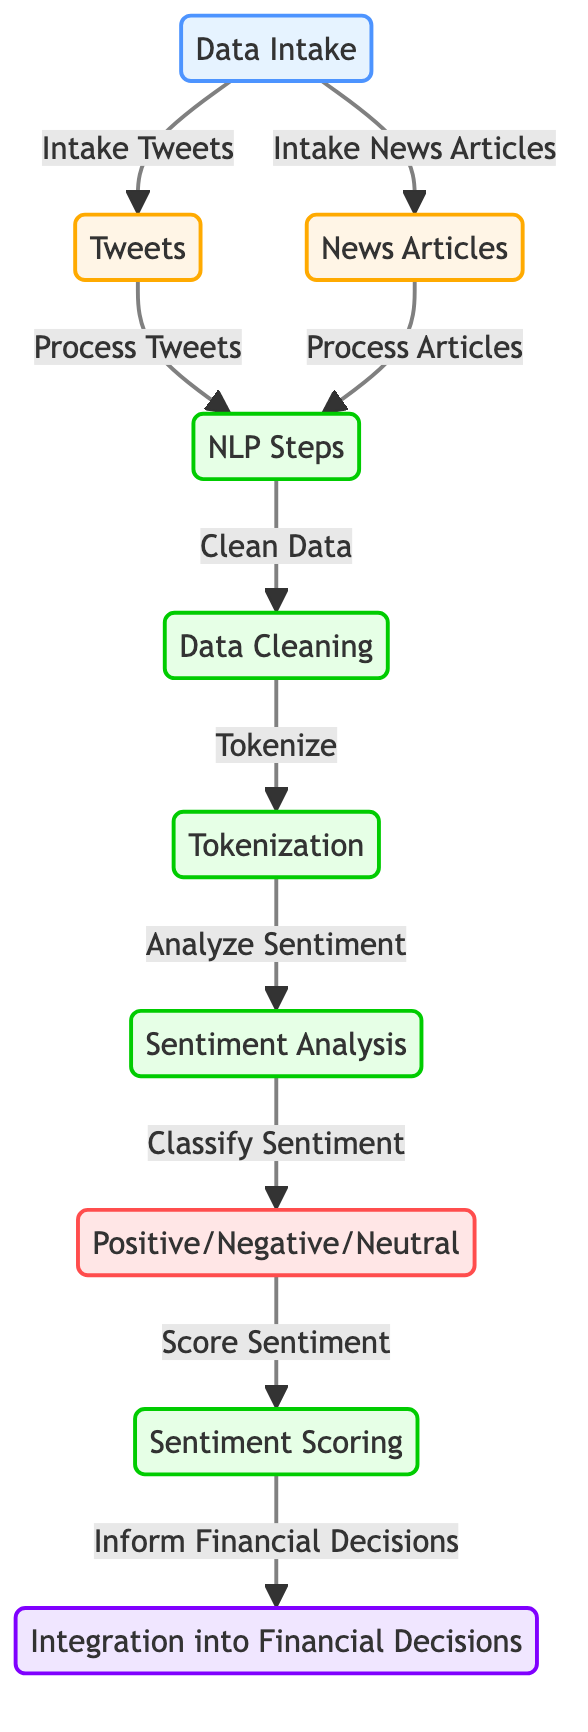What are the two sources of data intake in the diagram? The diagram indicates two sources for data intake: tweets and news articles, as labeled in the Data Intake node.
Answer: Tweets, news articles How many NLP steps are shown in the diagram? The diagram shows four steps under NLP: Data Cleaning, Tokenization, Sentiment Analysis, and Sentiment Scoring, which can be counted directly from the NLP Steps node leading downwards.
Answer: Four What is the final output of the diagram? The final output of the diagram is the Integration into Financial Decisions, which is the last node processed after scoring sentiment.
Answer: Integration into Financial Decisions What is the purpose of the Sentiment Analysis step? The Sentiment Analysis step classifies the sentiments from the processed text, distinguishing the emotional tone conveyed in the tweets and news articles.
Answer: Classify Sentiment Which nodes are classified as a process in the diagram? The nodes classified as a process are Data Cleaning, Tokenization, Sentiment Analysis, and Sentiment Scoring, all of which involve actions within the NLP framework.
Answer: Data Cleaning, Tokenization, Sentiment Analysis, Sentiment Scoring What comes after the Sentiment Analysis step in the flow? After the Sentiment Analysis step, the flow indicates that the sentiments are classified into Positive, Negative, or Neutral, which is the next step in the diagram.
Answer: Positive/Negative/Neutral How does data move from tweets to financial decision integration? Data flows first from tweets to the NLP Steps, then through various processing steps before arriving at the final decision integration, establishing a clear pathway from social media data to financial outcomes.
Answer: Through NLP Steps What is the classification result of sentiment in the diagram? The classification result of sentiment in the diagram is Positive, Negative, or Neutral, as shown in the corresponding node after Sentiment Analysis.
Answer: Positive/Negative/Neutral 